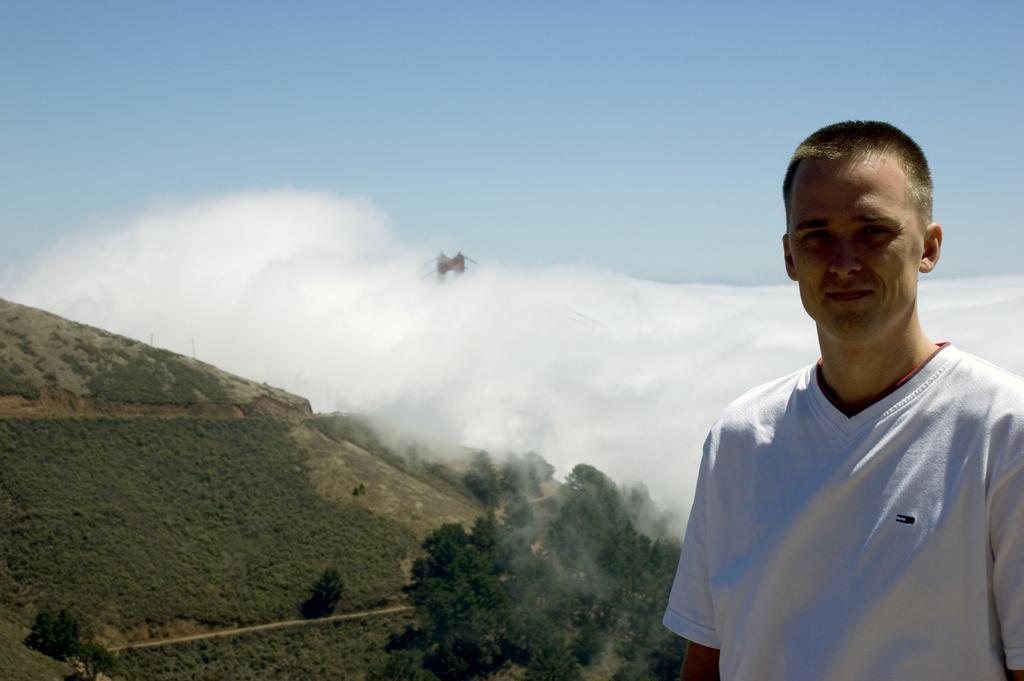In one or two sentences, can you explain what this image depicts? In this picture there is a man with white t-shirt is standing. At the back there is a mountain and there are trees on the mountain and it looks like a bridge and there are clouds. At the top there is sky. 